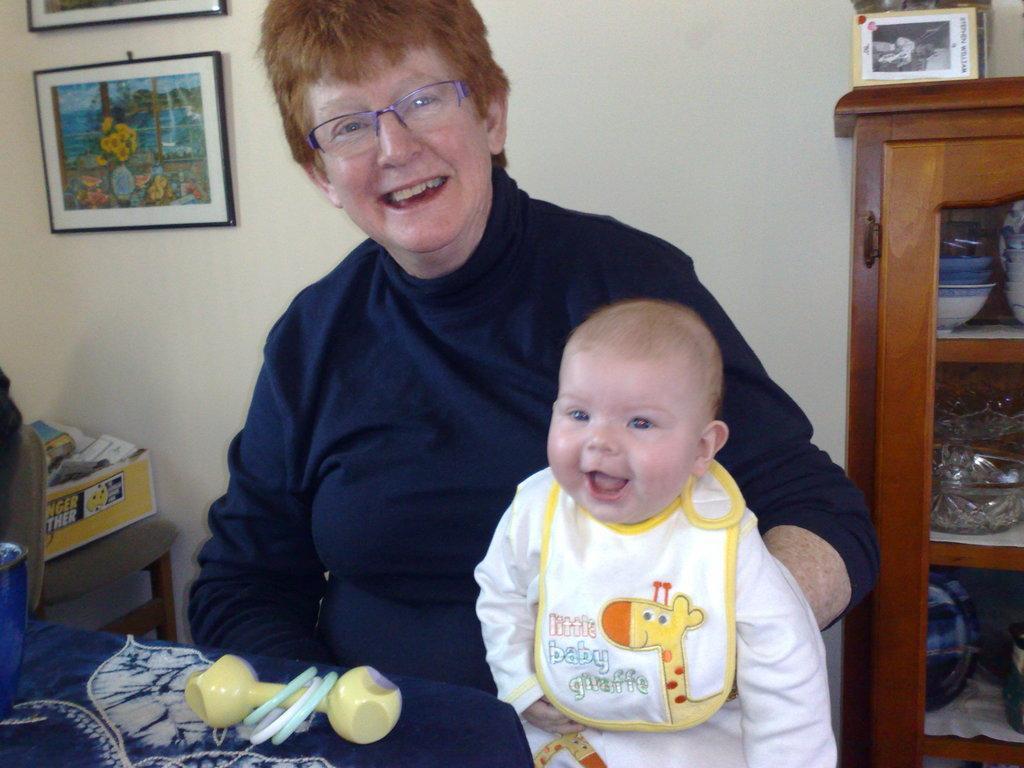Please provide a concise description of this image. This picture shows a woman and a baby and we see few photo frames on the wall and a cupboard with some bowls in it and we see a chair and a box on it and we see a bowl and a toy on the table and women were spectacles on her face. 